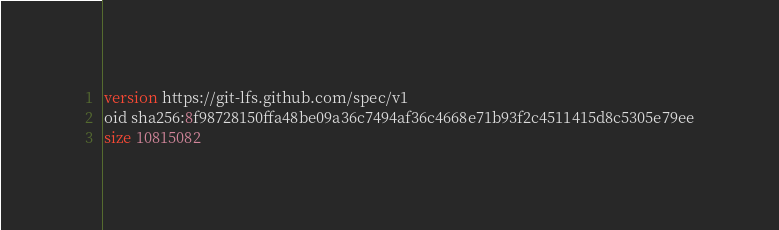<code> <loc_0><loc_0><loc_500><loc_500><_SQL_>version https://git-lfs.github.com/spec/v1
oid sha256:8f98728150ffa48be09a36c7494af36c4668e71b93f2c4511415d8c5305e79ee
size 10815082
</code> 